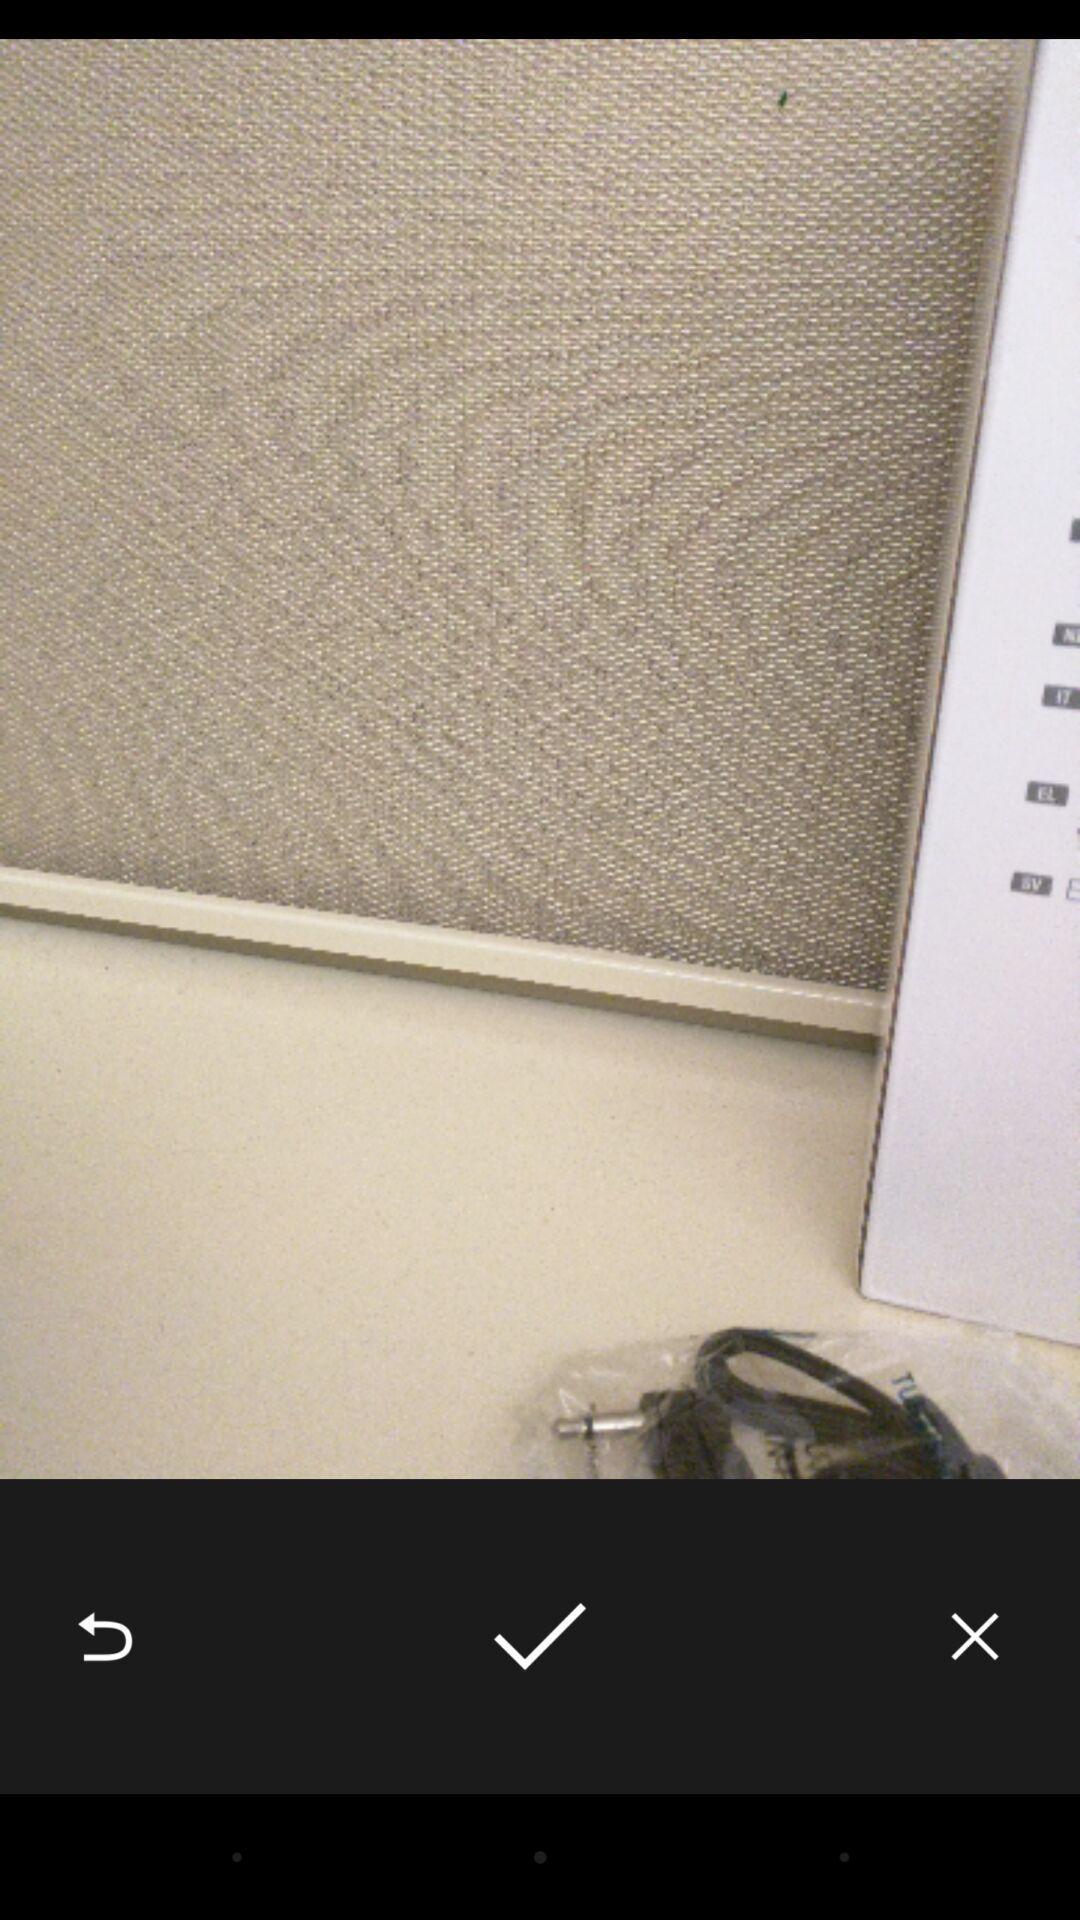Describe this image in words. Page displaying an image. 